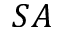Convert formula to latex. <formula><loc_0><loc_0><loc_500><loc_500>S A</formula> 